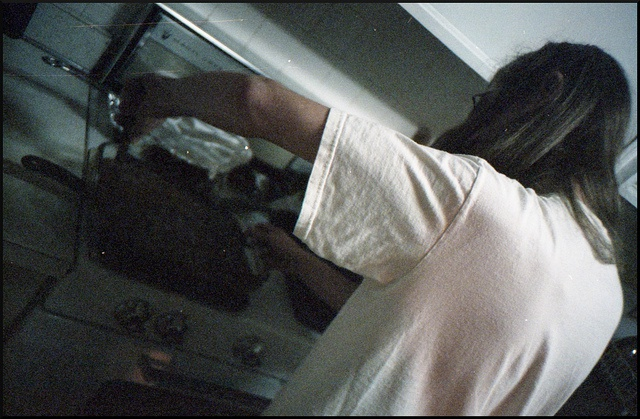Describe the objects in this image and their specific colors. I can see people in black, darkgray, lightgray, and gray tones and oven in black, darkgreen, and purple tones in this image. 